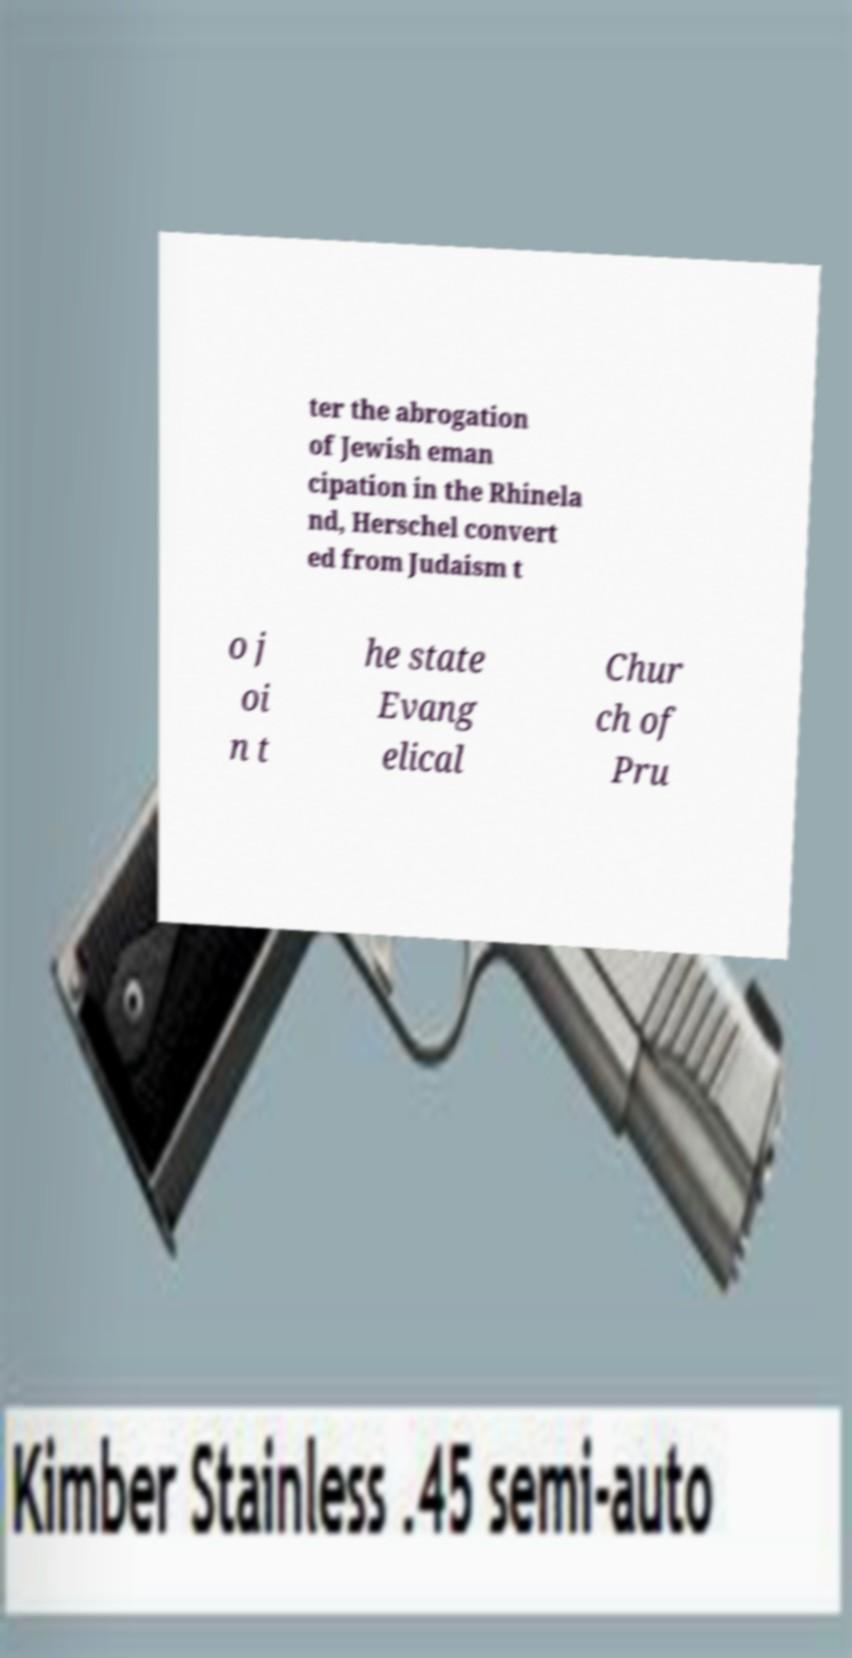Please identify and transcribe the text found in this image. ter the abrogation of Jewish eman cipation in the Rhinela nd, Herschel convert ed from Judaism t o j oi n t he state Evang elical Chur ch of Pru 